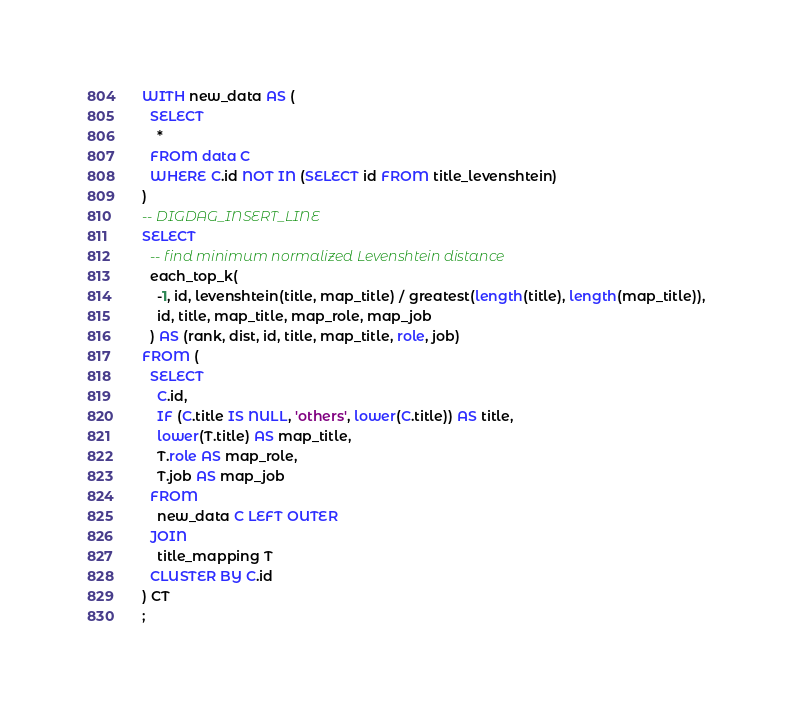<code> <loc_0><loc_0><loc_500><loc_500><_SQL_>WITH new_data AS (
  SELECT
    *
  FROM data C
  WHERE C.id NOT IN (SELECT id FROM title_levenshtein)
)
-- DIGDAG_INSERT_LINE
SELECT
  -- find minimum normalized Levenshtein distance
  each_top_k(
    -1, id, levenshtein(title, map_title) / greatest(length(title), length(map_title)),
    id, title, map_title, map_role, map_job
  ) AS (rank, dist, id, title, map_title, role, job)
FROM (
  SELECT
    C.id,
    IF (C.title IS NULL, 'others', lower(C.title)) AS title,
    lower(T.title) AS map_title,
    T.role AS map_role,
    T.job AS map_job
  FROM
    new_data C LEFT OUTER
  JOIN
    title_mapping T
  CLUSTER BY C.id
) CT
;
</code> 